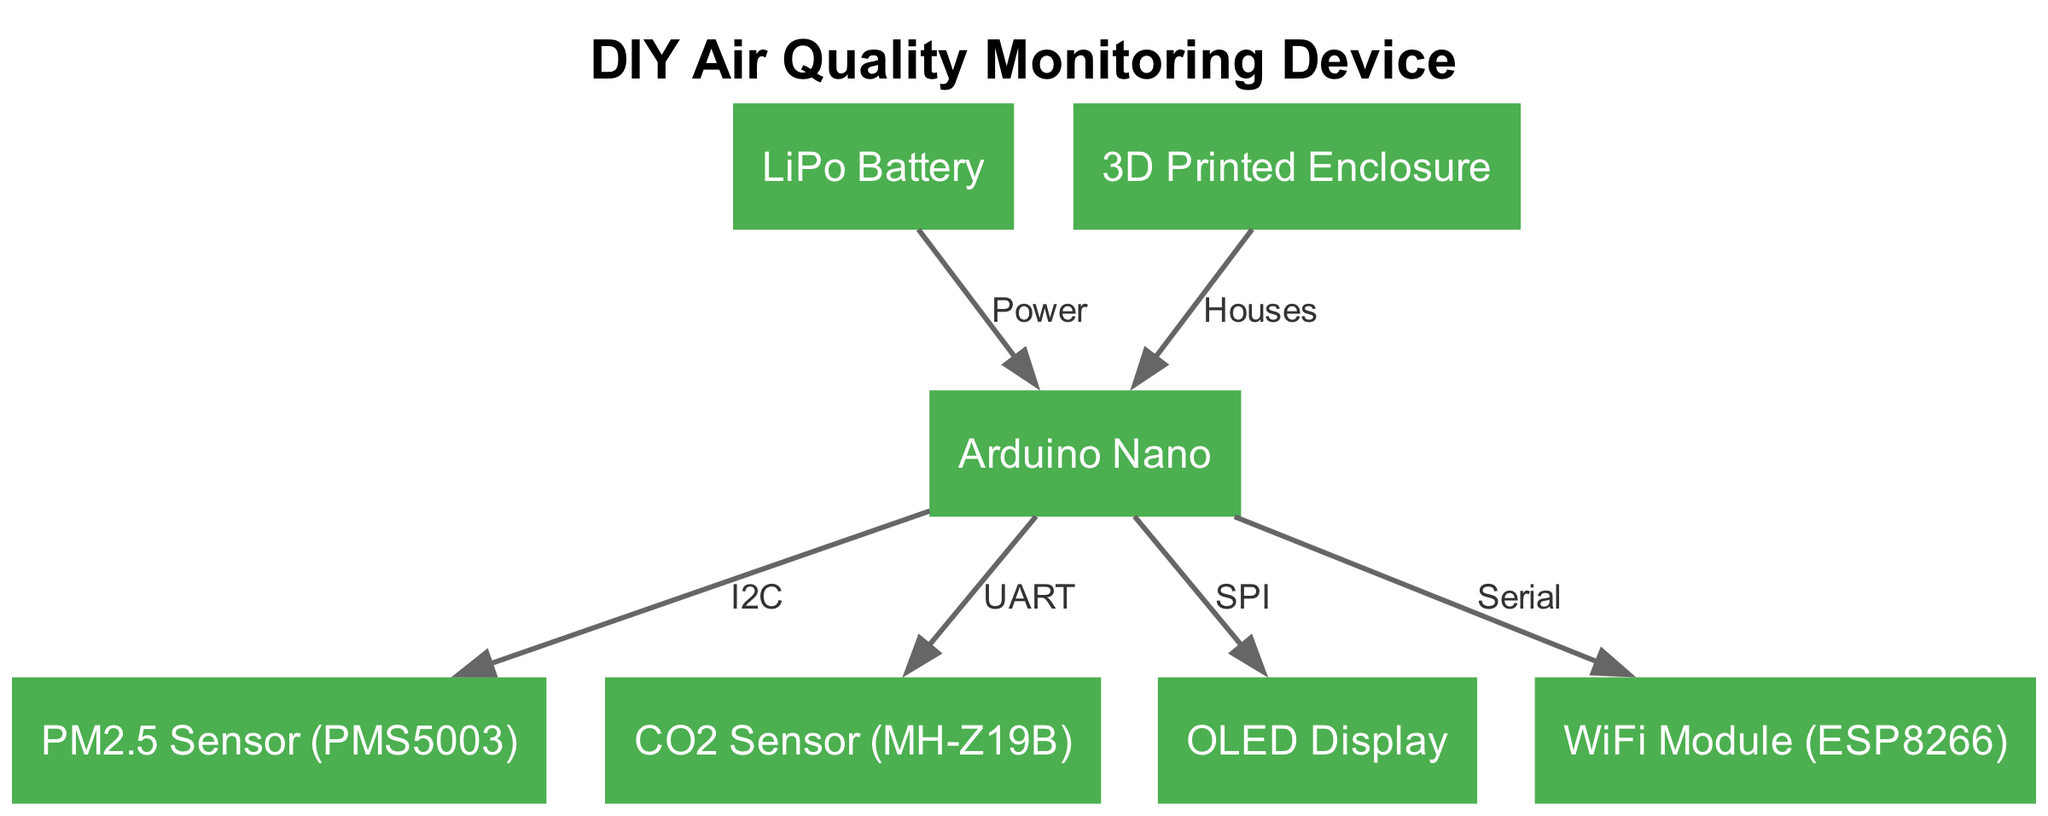What is the central element of the diagram? The central element of the diagram is the Arduino Nano, as it is connected to all other components.
Answer: Arduino Nano How many nodes are present in the diagram? By counting the individual components listed as nodes, we find there are seven components connected to the Arduino Nano.
Answer: 7 Which sensor is connected to the Arduino using I2C? The PM2.5 Sensor (PMS5003) is the one that uses the I2C connection to communicate with the Arduino Nano.
Answer: PM2.5 Sensor (PMS5003) What is the role of the LiPo Battery in the diagram? The LiPo Battery provides the power supply to the Arduino Nano, as indicated by the "Power" label on the edge connecting them.
Answer: Power What types of sensors are present in the diagram? There are two types of sensors: a PM2.5 sensor and a CO2 sensor, showing that the device monitors particulate matter and carbon dioxide.
Answer: PM2.5 sensor and CO2 sensor How many connections does the Arduino Nano have? The Arduino Nano connects to six components: the PM2.5 sensor, CO2 sensor, OLED display, WiFi module, LiPo battery, and 3D printed enclosure.
Answer: 6 What does the WiFi module connect to in the diagram? The WiFi module connects to the Arduino Nano through a Serial communication interface, as indicated by the respective edge in the diagram.
Answer: Arduino Nano Which component houses the Arduino Nano? The 3D printed enclosure provides a housing for the Arduino Nano, as depicted in the diagram with the edge labeled "Houses."
Answer: 3D Printed Enclosure 